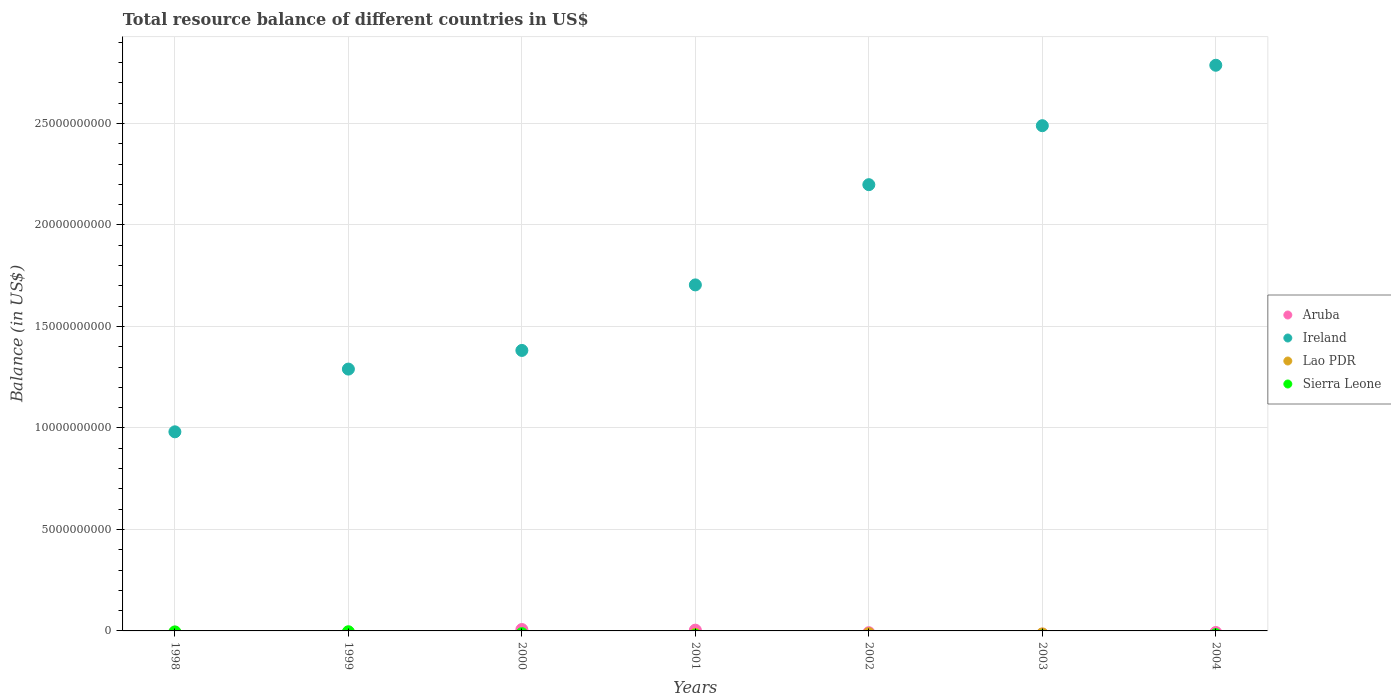Across all years, what is the maximum total resource balance in Aruba?
Offer a very short reply. 6.93e+07. Across all years, what is the minimum total resource balance in Sierra Leone?
Your answer should be very brief. 0. What is the total total resource balance in Lao PDR in the graph?
Provide a short and direct response. 0. What is the difference between the total resource balance in Ireland in 1998 and that in 2003?
Provide a succinct answer. -1.51e+1. What is the difference between the total resource balance in Ireland in 2004 and the total resource balance in Aruba in 2002?
Your response must be concise. 2.79e+1. What is the average total resource balance in Ireland per year?
Give a very brief answer. 1.83e+1. In the year 2001, what is the difference between the total resource balance in Ireland and total resource balance in Aruba?
Provide a succinct answer. 1.70e+1. What is the ratio of the total resource balance in Ireland in 1998 to that in 1999?
Make the answer very short. 0.76. What is the difference between the highest and the lowest total resource balance in Ireland?
Your answer should be very brief. 1.81e+1. Is the sum of the total resource balance in Ireland in 1999 and 2001 greater than the maximum total resource balance in Aruba across all years?
Offer a terse response. Yes. Does the total resource balance in Sierra Leone monotonically increase over the years?
Make the answer very short. No. Is the total resource balance in Sierra Leone strictly greater than the total resource balance in Lao PDR over the years?
Provide a succinct answer. No. How many dotlines are there?
Provide a short and direct response. 2. How many years are there in the graph?
Keep it short and to the point. 7. Does the graph contain grids?
Your response must be concise. Yes. What is the title of the graph?
Ensure brevity in your answer.  Total resource balance of different countries in US$. What is the label or title of the X-axis?
Keep it short and to the point. Years. What is the label or title of the Y-axis?
Provide a short and direct response. Balance (in US$). What is the Balance (in US$) in Ireland in 1998?
Provide a succinct answer. 9.81e+09. What is the Balance (in US$) of Sierra Leone in 1998?
Keep it short and to the point. 0. What is the Balance (in US$) of Ireland in 1999?
Your answer should be compact. 1.29e+1. What is the Balance (in US$) of Lao PDR in 1999?
Make the answer very short. 0. What is the Balance (in US$) of Aruba in 2000?
Offer a terse response. 6.93e+07. What is the Balance (in US$) in Ireland in 2000?
Make the answer very short. 1.38e+1. What is the Balance (in US$) of Sierra Leone in 2000?
Provide a short and direct response. 0. What is the Balance (in US$) of Aruba in 2001?
Your answer should be compact. 3.75e+07. What is the Balance (in US$) in Ireland in 2001?
Ensure brevity in your answer.  1.70e+1. What is the Balance (in US$) in Lao PDR in 2001?
Make the answer very short. 0. What is the Balance (in US$) in Sierra Leone in 2001?
Your response must be concise. 0. What is the Balance (in US$) in Ireland in 2002?
Ensure brevity in your answer.  2.20e+1. What is the Balance (in US$) of Lao PDR in 2002?
Your answer should be compact. 0. What is the Balance (in US$) of Aruba in 2003?
Your response must be concise. 0. What is the Balance (in US$) in Ireland in 2003?
Provide a short and direct response. 2.49e+1. What is the Balance (in US$) in Aruba in 2004?
Give a very brief answer. 0. What is the Balance (in US$) of Ireland in 2004?
Provide a succinct answer. 2.79e+1. What is the Balance (in US$) in Sierra Leone in 2004?
Your answer should be very brief. 0. Across all years, what is the maximum Balance (in US$) in Aruba?
Your response must be concise. 6.93e+07. Across all years, what is the maximum Balance (in US$) of Ireland?
Your answer should be compact. 2.79e+1. Across all years, what is the minimum Balance (in US$) in Ireland?
Give a very brief answer. 9.81e+09. What is the total Balance (in US$) of Aruba in the graph?
Your response must be concise. 1.07e+08. What is the total Balance (in US$) in Ireland in the graph?
Your answer should be compact. 1.28e+11. What is the difference between the Balance (in US$) of Ireland in 1998 and that in 1999?
Your answer should be compact. -3.09e+09. What is the difference between the Balance (in US$) in Ireland in 1998 and that in 2000?
Your answer should be compact. -4.01e+09. What is the difference between the Balance (in US$) of Ireland in 1998 and that in 2001?
Give a very brief answer. -7.24e+09. What is the difference between the Balance (in US$) in Ireland in 1998 and that in 2002?
Offer a terse response. -1.22e+1. What is the difference between the Balance (in US$) of Ireland in 1998 and that in 2003?
Ensure brevity in your answer.  -1.51e+1. What is the difference between the Balance (in US$) of Ireland in 1998 and that in 2004?
Your answer should be very brief. -1.81e+1. What is the difference between the Balance (in US$) of Ireland in 1999 and that in 2000?
Your answer should be compact. -9.19e+08. What is the difference between the Balance (in US$) in Ireland in 1999 and that in 2001?
Your answer should be compact. -4.15e+09. What is the difference between the Balance (in US$) in Ireland in 1999 and that in 2002?
Provide a succinct answer. -9.09e+09. What is the difference between the Balance (in US$) in Ireland in 1999 and that in 2003?
Provide a succinct answer. -1.20e+1. What is the difference between the Balance (in US$) of Ireland in 1999 and that in 2004?
Your answer should be compact. -1.50e+1. What is the difference between the Balance (in US$) of Aruba in 2000 and that in 2001?
Keep it short and to the point. 3.18e+07. What is the difference between the Balance (in US$) in Ireland in 2000 and that in 2001?
Keep it short and to the point. -3.23e+09. What is the difference between the Balance (in US$) of Ireland in 2000 and that in 2002?
Provide a succinct answer. -8.17e+09. What is the difference between the Balance (in US$) of Ireland in 2000 and that in 2003?
Offer a very short reply. -1.11e+1. What is the difference between the Balance (in US$) of Ireland in 2000 and that in 2004?
Offer a very short reply. -1.41e+1. What is the difference between the Balance (in US$) in Ireland in 2001 and that in 2002?
Provide a succinct answer. -4.94e+09. What is the difference between the Balance (in US$) of Ireland in 2001 and that in 2003?
Ensure brevity in your answer.  -7.84e+09. What is the difference between the Balance (in US$) of Ireland in 2001 and that in 2004?
Offer a very short reply. -1.08e+1. What is the difference between the Balance (in US$) of Ireland in 2002 and that in 2003?
Give a very brief answer. -2.91e+09. What is the difference between the Balance (in US$) in Ireland in 2002 and that in 2004?
Offer a very short reply. -5.88e+09. What is the difference between the Balance (in US$) in Ireland in 2003 and that in 2004?
Offer a terse response. -2.98e+09. What is the difference between the Balance (in US$) of Aruba in 2000 and the Balance (in US$) of Ireland in 2001?
Offer a very short reply. -1.70e+1. What is the difference between the Balance (in US$) of Aruba in 2000 and the Balance (in US$) of Ireland in 2002?
Offer a terse response. -2.19e+1. What is the difference between the Balance (in US$) in Aruba in 2000 and the Balance (in US$) in Ireland in 2003?
Provide a succinct answer. -2.48e+1. What is the difference between the Balance (in US$) in Aruba in 2000 and the Balance (in US$) in Ireland in 2004?
Offer a very short reply. -2.78e+1. What is the difference between the Balance (in US$) of Aruba in 2001 and the Balance (in US$) of Ireland in 2002?
Ensure brevity in your answer.  -2.19e+1. What is the difference between the Balance (in US$) in Aruba in 2001 and the Balance (in US$) in Ireland in 2003?
Ensure brevity in your answer.  -2.49e+1. What is the difference between the Balance (in US$) in Aruba in 2001 and the Balance (in US$) in Ireland in 2004?
Your answer should be compact. -2.78e+1. What is the average Balance (in US$) of Aruba per year?
Provide a succinct answer. 1.53e+07. What is the average Balance (in US$) of Ireland per year?
Provide a succinct answer. 1.83e+1. In the year 2000, what is the difference between the Balance (in US$) of Aruba and Balance (in US$) of Ireland?
Offer a terse response. -1.38e+1. In the year 2001, what is the difference between the Balance (in US$) of Aruba and Balance (in US$) of Ireland?
Offer a very short reply. -1.70e+1. What is the ratio of the Balance (in US$) of Ireland in 1998 to that in 1999?
Provide a succinct answer. 0.76. What is the ratio of the Balance (in US$) of Ireland in 1998 to that in 2000?
Give a very brief answer. 0.71. What is the ratio of the Balance (in US$) of Ireland in 1998 to that in 2001?
Keep it short and to the point. 0.58. What is the ratio of the Balance (in US$) of Ireland in 1998 to that in 2002?
Provide a short and direct response. 0.45. What is the ratio of the Balance (in US$) in Ireland in 1998 to that in 2003?
Keep it short and to the point. 0.39. What is the ratio of the Balance (in US$) of Ireland in 1998 to that in 2004?
Provide a short and direct response. 0.35. What is the ratio of the Balance (in US$) of Ireland in 1999 to that in 2000?
Your answer should be very brief. 0.93. What is the ratio of the Balance (in US$) in Ireland in 1999 to that in 2001?
Your answer should be compact. 0.76. What is the ratio of the Balance (in US$) of Ireland in 1999 to that in 2002?
Offer a terse response. 0.59. What is the ratio of the Balance (in US$) of Ireland in 1999 to that in 2003?
Offer a very short reply. 0.52. What is the ratio of the Balance (in US$) in Ireland in 1999 to that in 2004?
Your response must be concise. 0.46. What is the ratio of the Balance (in US$) in Aruba in 2000 to that in 2001?
Provide a short and direct response. 1.85. What is the ratio of the Balance (in US$) of Ireland in 2000 to that in 2001?
Your answer should be compact. 0.81. What is the ratio of the Balance (in US$) of Ireland in 2000 to that in 2002?
Provide a short and direct response. 0.63. What is the ratio of the Balance (in US$) of Ireland in 2000 to that in 2003?
Offer a terse response. 0.56. What is the ratio of the Balance (in US$) in Ireland in 2000 to that in 2004?
Make the answer very short. 0.5. What is the ratio of the Balance (in US$) of Ireland in 2001 to that in 2002?
Ensure brevity in your answer.  0.78. What is the ratio of the Balance (in US$) of Ireland in 2001 to that in 2003?
Ensure brevity in your answer.  0.68. What is the ratio of the Balance (in US$) in Ireland in 2001 to that in 2004?
Provide a short and direct response. 0.61. What is the ratio of the Balance (in US$) of Ireland in 2002 to that in 2003?
Make the answer very short. 0.88. What is the ratio of the Balance (in US$) in Ireland in 2002 to that in 2004?
Offer a terse response. 0.79. What is the ratio of the Balance (in US$) of Ireland in 2003 to that in 2004?
Provide a short and direct response. 0.89. What is the difference between the highest and the second highest Balance (in US$) in Ireland?
Offer a very short reply. 2.98e+09. What is the difference between the highest and the lowest Balance (in US$) in Aruba?
Your answer should be very brief. 6.93e+07. What is the difference between the highest and the lowest Balance (in US$) in Ireland?
Your response must be concise. 1.81e+1. 